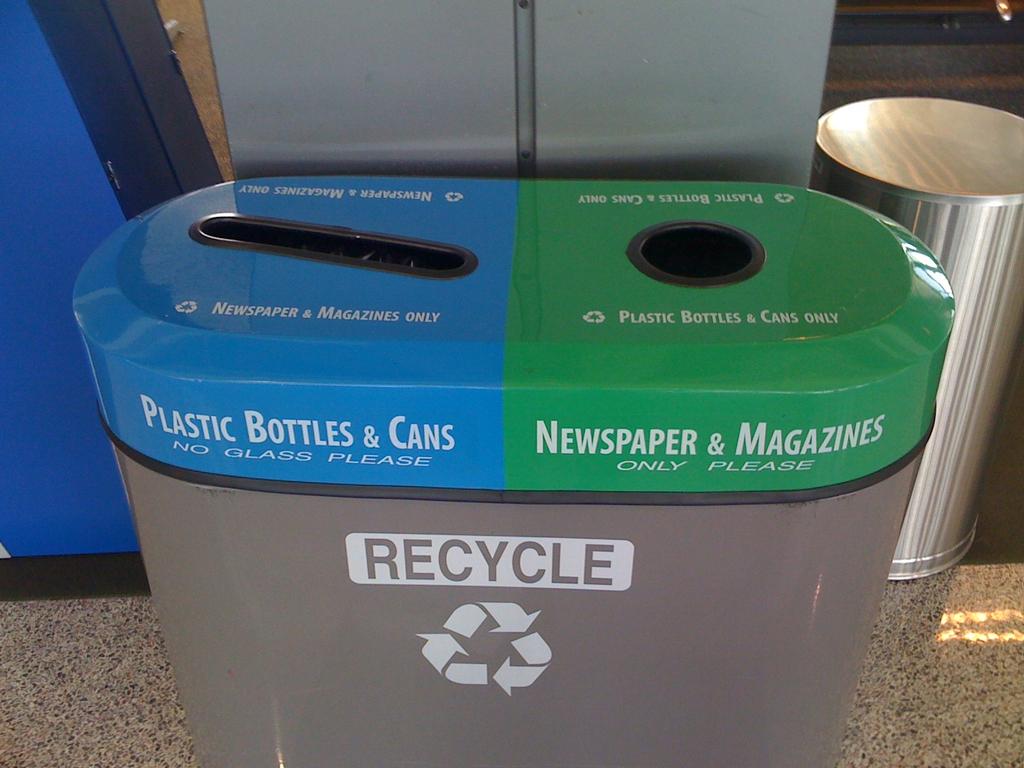What goes in the green column?
Provide a succinct answer. Newspaper & magazines. What does the bin say to do on the grey area?
Ensure brevity in your answer.  Recycle. 